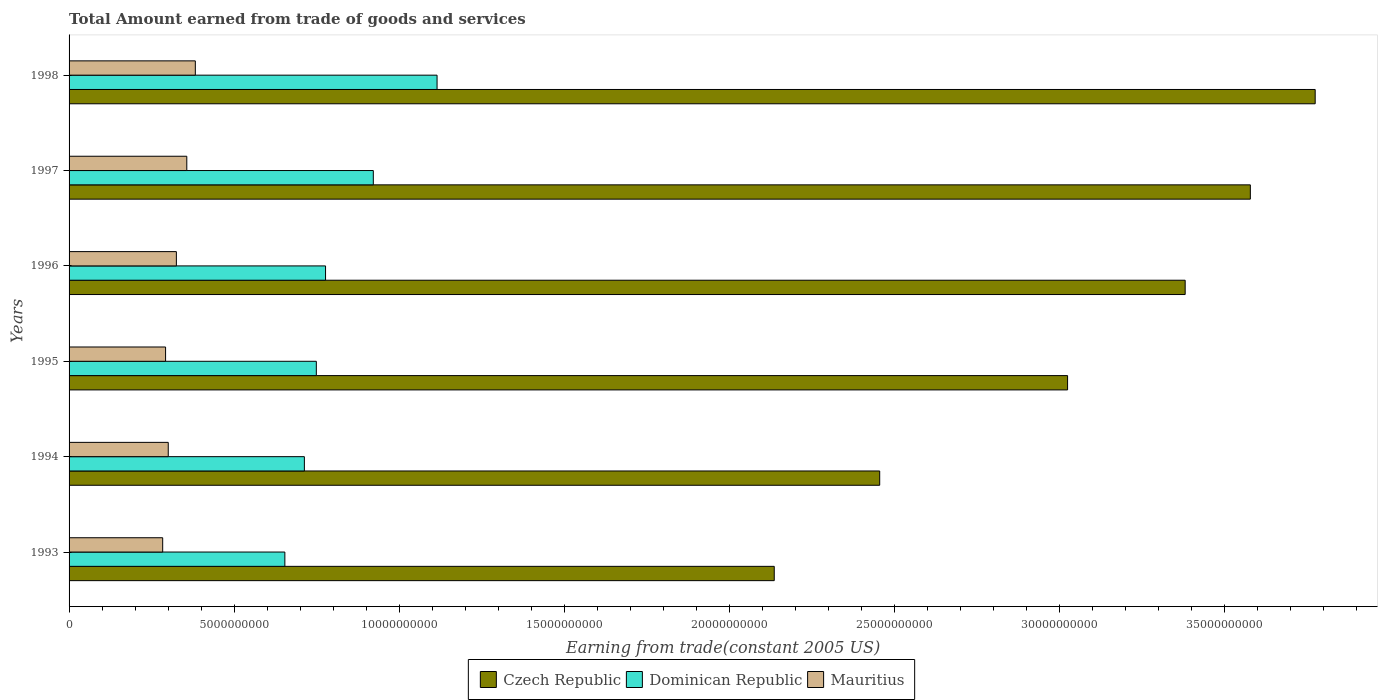How many different coloured bars are there?
Offer a very short reply. 3. How many groups of bars are there?
Offer a very short reply. 6. Are the number of bars on each tick of the Y-axis equal?
Your response must be concise. Yes. How many bars are there on the 1st tick from the top?
Make the answer very short. 3. How many bars are there on the 1st tick from the bottom?
Ensure brevity in your answer.  3. What is the label of the 3rd group of bars from the top?
Keep it short and to the point. 1996. What is the total amount earned by trading goods and services in Dominican Republic in 1993?
Your answer should be compact. 6.54e+09. Across all years, what is the maximum total amount earned by trading goods and services in Dominican Republic?
Make the answer very short. 1.12e+1. Across all years, what is the minimum total amount earned by trading goods and services in Mauritius?
Give a very brief answer. 2.84e+09. In which year was the total amount earned by trading goods and services in Dominican Republic maximum?
Your answer should be compact. 1998. What is the total total amount earned by trading goods and services in Czech Republic in the graph?
Offer a terse response. 1.84e+11. What is the difference between the total amount earned by trading goods and services in Czech Republic in 1994 and that in 1995?
Your response must be concise. -5.69e+09. What is the difference between the total amount earned by trading goods and services in Mauritius in 1994 and the total amount earned by trading goods and services in Dominican Republic in 1997?
Offer a very short reply. -6.21e+09. What is the average total amount earned by trading goods and services in Mauritius per year?
Offer a very short reply. 3.24e+09. In the year 1998, what is the difference between the total amount earned by trading goods and services in Czech Republic and total amount earned by trading goods and services in Mauritius?
Offer a terse response. 3.39e+1. In how many years, is the total amount earned by trading goods and services in Dominican Republic greater than 37000000000 US$?
Your answer should be very brief. 0. What is the ratio of the total amount earned by trading goods and services in Czech Republic in 1995 to that in 1997?
Your response must be concise. 0.85. What is the difference between the highest and the second highest total amount earned by trading goods and services in Dominican Republic?
Offer a very short reply. 1.93e+09. What is the difference between the highest and the lowest total amount earned by trading goods and services in Czech Republic?
Provide a succinct answer. 1.64e+1. In how many years, is the total amount earned by trading goods and services in Mauritius greater than the average total amount earned by trading goods and services in Mauritius taken over all years?
Keep it short and to the point. 3. Is the sum of the total amount earned by trading goods and services in Dominican Republic in 1994 and 1995 greater than the maximum total amount earned by trading goods and services in Czech Republic across all years?
Provide a short and direct response. No. What does the 3rd bar from the top in 1993 represents?
Offer a terse response. Czech Republic. What does the 2nd bar from the bottom in 1998 represents?
Offer a very short reply. Dominican Republic. How many bars are there?
Offer a terse response. 18. What is the difference between two consecutive major ticks on the X-axis?
Keep it short and to the point. 5.00e+09. How many legend labels are there?
Offer a terse response. 3. How are the legend labels stacked?
Keep it short and to the point. Horizontal. What is the title of the graph?
Your answer should be compact. Total Amount earned from trade of goods and services. What is the label or title of the X-axis?
Provide a short and direct response. Earning from trade(constant 2005 US). What is the Earning from trade(constant 2005 US) of Czech Republic in 1993?
Give a very brief answer. 2.14e+1. What is the Earning from trade(constant 2005 US) in Dominican Republic in 1993?
Give a very brief answer. 6.54e+09. What is the Earning from trade(constant 2005 US) in Mauritius in 1993?
Ensure brevity in your answer.  2.84e+09. What is the Earning from trade(constant 2005 US) of Czech Republic in 1994?
Make the answer very short. 2.46e+1. What is the Earning from trade(constant 2005 US) of Dominican Republic in 1994?
Your response must be concise. 7.13e+09. What is the Earning from trade(constant 2005 US) of Mauritius in 1994?
Keep it short and to the point. 3.01e+09. What is the Earning from trade(constant 2005 US) of Czech Republic in 1995?
Make the answer very short. 3.03e+1. What is the Earning from trade(constant 2005 US) in Dominican Republic in 1995?
Your response must be concise. 7.49e+09. What is the Earning from trade(constant 2005 US) of Mauritius in 1995?
Make the answer very short. 2.92e+09. What is the Earning from trade(constant 2005 US) in Czech Republic in 1996?
Offer a terse response. 3.38e+1. What is the Earning from trade(constant 2005 US) of Dominican Republic in 1996?
Your answer should be very brief. 7.77e+09. What is the Earning from trade(constant 2005 US) in Mauritius in 1996?
Offer a very short reply. 3.25e+09. What is the Earning from trade(constant 2005 US) of Czech Republic in 1997?
Offer a terse response. 3.58e+1. What is the Earning from trade(constant 2005 US) of Dominican Republic in 1997?
Keep it short and to the point. 9.22e+09. What is the Earning from trade(constant 2005 US) in Mauritius in 1997?
Your answer should be very brief. 3.57e+09. What is the Earning from trade(constant 2005 US) of Czech Republic in 1998?
Your answer should be compact. 3.78e+1. What is the Earning from trade(constant 2005 US) of Dominican Republic in 1998?
Provide a succinct answer. 1.12e+1. What is the Earning from trade(constant 2005 US) in Mauritius in 1998?
Make the answer very short. 3.83e+09. Across all years, what is the maximum Earning from trade(constant 2005 US) in Czech Republic?
Your response must be concise. 3.78e+1. Across all years, what is the maximum Earning from trade(constant 2005 US) in Dominican Republic?
Your response must be concise. 1.12e+1. Across all years, what is the maximum Earning from trade(constant 2005 US) of Mauritius?
Your answer should be very brief. 3.83e+09. Across all years, what is the minimum Earning from trade(constant 2005 US) in Czech Republic?
Ensure brevity in your answer.  2.14e+1. Across all years, what is the minimum Earning from trade(constant 2005 US) of Dominican Republic?
Offer a terse response. 6.54e+09. Across all years, what is the minimum Earning from trade(constant 2005 US) of Mauritius?
Your answer should be compact. 2.84e+09. What is the total Earning from trade(constant 2005 US) in Czech Republic in the graph?
Your answer should be compact. 1.84e+11. What is the total Earning from trade(constant 2005 US) in Dominican Republic in the graph?
Ensure brevity in your answer.  4.93e+1. What is the total Earning from trade(constant 2005 US) in Mauritius in the graph?
Your response must be concise. 1.94e+1. What is the difference between the Earning from trade(constant 2005 US) in Czech Republic in 1993 and that in 1994?
Your response must be concise. -3.20e+09. What is the difference between the Earning from trade(constant 2005 US) of Dominican Republic in 1993 and that in 1994?
Offer a terse response. -5.92e+08. What is the difference between the Earning from trade(constant 2005 US) of Mauritius in 1993 and that in 1994?
Give a very brief answer. -1.69e+08. What is the difference between the Earning from trade(constant 2005 US) of Czech Republic in 1993 and that in 1995?
Offer a very short reply. -8.89e+09. What is the difference between the Earning from trade(constant 2005 US) of Dominican Republic in 1993 and that in 1995?
Give a very brief answer. -9.54e+08. What is the difference between the Earning from trade(constant 2005 US) in Mauritius in 1993 and that in 1995?
Your answer should be very brief. -8.80e+07. What is the difference between the Earning from trade(constant 2005 US) of Czech Republic in 1993 and that in 1996?
Your answer should be very brief. -1.25e+1. What is the difference between the Earning from trade(constant 2005 US) of Dominican Republic in 1993 and that in 1996?
Give a very brief answer. -1.23e+09. What is the difference between the Earning from trade(constant 2005 US) of Mauritius in 1993 and that in 1996?
Offer a terse response. -4.15e+08. What is the difference between the Earning from trade(constant 2005 US) of Czech Republic in 1993 and that in 1997?
Offer a terse response. -1.44e+1. What is the difference between the Earning from trade(constant 2005 US) in Dominican Republic in 1993 and that in 1997?
Keep it short and to the point. -2.68e+09. What is the difference between the Earning from trade(constant 2005 US) of Mauritius in 1993 and that in 1997?
Your answer should be very brief. -7.31e+08. What is the difference between the Earning from trade(constant 2005 US) of Czech Republic in 1993 and that in 1998?
Provide a short and direct response. -1.64e+1. What is the difference between the Earning from trade(constant 2005 US) in Dominican Republic in 1993 and that in 1998?
Keep it short and to the point. -4.61e+09. What is the difference between the Earning from trade(constant 2005 US) in Mauritius in 1993 and that in 1998?
Your response must be concise. -9.90e+08. What is the difference between the Earning from trade(constant 2005 US) of Czech Republic in 1994 and that in 1995?
Your answer should be very brief. -5.69e+09. What is the difference between the Earning from trade(constant 2005 US) of Dominican Republic in 1994 and that in 1995?
Give a very brief answer. -3.62e+08. What is the difference between the Earning from trade(constant 2005 US) of Mauritius in 1994 and that in 1995?
Your answer should be very brief. 8.09e+07. What is the difference between the Earning from trade(constant 2005 US) of Czech Republic in 1994 and that in 1996?
Your answer should be compact. -9.26e+09. What is the difference between the Earning from trade(constant 2005 US) in Dominican Republic in 1994 and that in 1996?
Your response must be concise. -6.42e+08. What is the difference between the Earning from trade(constant 2005 US) of Mauritius in 1994 and that in 1996?
Provide a short and direct response. -2.46e+08. What is the difference between the Earning from trade(constant 2005 US) in Czech Republic in 1994 and that in 1997?
Provide a short and direct response. -1.12e+1. What is the difference between the Earning from trade(constant 2005 US) of Dominican Republic in 1994 and that in 1997?
Keep it short and to the point. -2.09e+09. What is the difference between the Earning from trade(constant 2005 US) of Mauritius in 1994 and that in 1997?
Your answer should be very brief. -5.62e+08. What is the difference between the Earning from trade(constant 2005 US) of Czech Republic in 1994 and that in 1998?
Keep it short and to the point. -1.32e+1. What is the difference between the Earning from trade(constant 2005 US) in Dominican Republic in 1994 and that in 1998?
Provide a succinct answer. -4.02e+09. What is the difference between the Earning from trade(constant 2005 US) in Mauritius in 1994 and that in 1998?
Your response must be concise. -8.21e+08. What is the difference between the Earning from trade(constant 2005 US) of Czech Republic in 1995 and that in 1996?
Keep it short and to the point. -3.56e+09. What is the difference between the Earning from trade(constant 2005 US) in Dominican Republic in 1995 and that in 1996?
Ensure brevity in your answer.  -2.80e+08. What is the difference between the Earning from trade(constant 2005 US) in Mauritius in 1995 and that in 1996?
Offer a very short reply. -3.27e+08. What is the difference between the Earning from trade(constant 2005 US) in Czech Republic in 1995 and that in 1997?
Ensure brevity in your answer.  -5.54e+09. What is the difference between the Earning from trade(constant 2005 US) of Dominican Republic in 1995 and that in 1997?
Offer a very short reply. -1.73e+09. What is the difference between the Earning from trade(constant 2005 US) of Mauritius in 1995 and that in 1997?
Provide a short and direct response. -6.43e+08. What is the difference between the Earning from trade(constant 2005 US) of Czech Republic in 1995 and that in 1998?
Your answer should be compact. -7.50e+09. What is the difference between the Earning from trade(constant 2005 US) of Dominican Republic in 1995 and that in 1998?
Offer a terse response. -3.66e+09. What is the difference between the Earning from trade(constant 2005 US) in Mauritius in 1995 and that in 1998?
Offer a terse response. -9.02e+08. What is the difference between the Earning from trade(constant 2005 US) of Czech Republic in 1996 and that in 1997?
Your response must be concise. -1.97e+09. What is the difference between the Earning from trade(constant 2005 US) in Dominican Republic in 1996 and that in 1997?
Provide a succinct answer. -1.45e+09. What is the difference between the Earning from trade(constant 2005 US) of Mauritius in 1996 and that in 1997?
Your answer should be compact. -3.16e+08. What is the difference between the Earning from trade(constant 2005 US) of Czech Republic in 1996 and that in 1998?
Ensure brevity in your answer.  -3.94e+09. What is the difference between the Earning from trade(constant 2005 US) of Dominican Republic in 1996 and that in 1998?
Provide a short and direct response. -3.38e+09. What is the difference between the Earning from trade(constant 2005 US) of Mauritius in 1996 and that in 1998?
Offer a very short reply. -5.74e+08. What is the difference between the Earning from trade(constant 2005 US) of Czech Republic in 1997 and that in 1998?
Make the answer very short. -1.97e+09. What is the difference between the Earning from trade(constant 2005 US) of Dominican Republic in 1997 and that in 1998?
Offer a very short reply. -1.93e+09. What is the difference between the Earning from trade(constant 2005 US) in Mauritius in 1997 and that in 1998?
Offer a terse response. -2.59e+08. What is the difference between the Earning from trade(constant 2005 US) of Czech Republic in 1993 and the Earning from trade(constant 2005 US) of Dominican Republic in 1994?
Provide a short and direct response. 1.42e+1. What is the difference between the Earning from trade(constant 2005 US) in Czech Republic in 1993 and the Earning from trade(constant 2005 US) in Mauritius in 1994?
Provide a succinct answer. 1.84e+1. What is the difference between the Earning from trade(constant 2005 US) in Dominican Republic in 1993 and the Earning from trade(constant 2005 US) in Mauritius in 1994?
Keep it short and to the point. 3.53e+09. What is the difference between the Earning from trade(constant 2005 US) in Czech Republic in 1993 and the Earning from trade(constant 2005 US) in Dominican Republic in 1995?
Your response must be concise. 1.39e+1. What is the difference between the Earning from trade(constant 2005 US) in Czech Republic in 1993 and the Earning from trade(constant 2005 US) in Mauritius in 1995?
Make the answer very short. 1.84e+1. What is the difference between the Earning from trade(constant 2005 US) of Dominican Republic in 1993 and the Earning from trade(constant 2005 US) of Mauritius in 1995?
Provide a short and direct response. 3.61e+09. What is the difference between the Earning from trade(constant 2005 US) of Czech Republic in 1993 and the Earning from trade(constant 2005 US) of Dominican Republic in 1996?
Your answer should be very brief. 1.36e+1. What is the difference between the Earning from trade(constant 2005 US) of Czech Republic in 1993 and the Earning from trade(constant 2005 US) of Mauritius in 1996?
Offer a very short reply. 1.81e+1. What is the difference between the Earning from trade(constant 2005 US) of Dominican Republic in 1993 and the Earning from trade(constant 2005 US) of Mauritius in 1996?
Offer a terse response. 3.29e+09. What is the difference between the Earning from trade(constant 2005 US) of Czech Republic in 1993 and the Earning from trade(constant 2005 US) of Dominican Republic in 1997?
Your answer should be compact. 1.22e+1. What is the difference between the Earning from trade(constant 2005 US) of Czech Republic in 1993 and the Earning from trade(constant 2005 US) of Mauritius in 1997?
Offer a terse response. 1.78e+1. What is the difference between the Earning from trade(constant 2005 US) in Dominican Republic in 1993 and the Earning from trade(constant 2005 US) in Mauritius in 1997?
Ensure brevity in your answer.  2.97e+09. What is the difference between the Earning from trade(constant 2005 US) of Czech Republic in 1993 and the Earning from trade(constant 2005 US) of Dominican Republic in 1998?
Provide a short and direct response. 1.02e+1. What is the difference between the Earning from trade(constant 2005 US) in Czech Republic in 1993 and the Earning from trade(constant 2005 US) in Mauritius in 1998?
Offer a very short reply. 1.75e+1. What is the difference between the Earning from trade(constant 2005 US) in Dominican Republic in 1993 and the Earning from trade(constant 2005 US) in Mauritius in 1998?
Your answer should be compact. 2.71e+09. What is the difference between the Earning from trade(constant 2005 US) of Czech Republic in 1994 and the Earning from trade(constant 2005 US) of Dominican Republic in 1995?
Make the answer very short. 1.71e+1. What is the difference between the Earning from trade(constant 2005 US) of Czech Republic in 1994 and the Earning from trade(constant 2005 US) of Mauritius in 1995?
Give a very brief answer. 2.16e+1. What is the difference between the Earning from trade(constant 2005 US) of Dominican Republic in 1994 and the Earning from trade(constant 2005 US) of Mauritius in 1995?
Offer a very short reply. 4.21e+09. What is the difference between the Earning from trade(constant 2005 US) of Czech Republic in 1994 and the Earning from trade(constant 2005 US) of Dominican Republic in 1996?
Offer a terse response. 1.68e+1. What is the difference between the Earning from trade(constant 2005 US) of Czech Republic in 1994 and the Earning from trade(constant 2005 US) of Mauritius in 1996?
Provide a succinct answer. 2.13e+1. What is the difference between the Earning from trade(constant 2005 US) of Dominican Republic in 1994 and the Earning from trade(constant 2005 US) of Mauritius in 1996?
Your answer should be very brief. 3.88e+09. What is the difference between the Earning from trade(constant 2005 US) in Czech Republic in 1994 and the Earning from trade(constant 2005 US) in Dominican Republic in 1997?
Ensure brevity in your answer.  1.53e+1. What is the difference between the Earning from trade(constant 2005 US) in Czech Republic in 1994 and the Earning from trade(constant 2005 US) in Mauritius in 1997?
Ensure brevity in your answer.  2.10e+1. What is the difference between the Earning from trade(constant 2005 US) in Dominican Republic in 1994 and the Earning from trade(constant 2005 US) in Mauritius in 1997?
Give a very brief answer. 3.56e+09. What is the difference between the Earning from trade(constant 2005 US) of Czech Republic in 1994 and the Earning from trade(constant 2005 US) of Dominican Republic in 1998?
Your answer should be compact. 1.34e+1. What is the difference between the Earning from trade(constant 2005 US) of Czech Republic in 1994 and the Earning from trade(constant 2005 US) of Mauritius in 1998?
Provide a short and direct response. 2.07e+1. What is the difference between the Earning from trade(constant 2005 US) of Dominican Republic in 1994 and the Earning from trade(constant 2005 US) of Mauritius in 1998?
Provide a short and direct response. 3.30e+09. What is the difference between the Earning from trade(constant 2005 US) in Czech Republic in 1995 and the Earning from trade(constant 2005 US) in Dominican Republic in 1996?
Provide a short and direct response. 2.25e+1. What is the difference between the Earning from trade(constant 2005 US) in Czech Republic in 1995 and the Earning from trade(constant 2005 US) in Mauritius in 1996?
Keep it short and to the point. 2.70e+1. What is the difference between the Earning from trade(constant 2005 US) of Dominican Republic in 1995 and the Earning from trade(constant 2005 US) of Mauritius in 1996?
Give a very brief answer. 4.24e+09. What is the difference between the Earning from trade(constant 2005 US) of Czech Republic in 1995 and the Earning from trade(constant 2005 US) of Dominican Republic in 1997?
Provide a succinct answer. 2.10e+1. What is the difference between the Earning from trade(constant 2005 US) in Czech Republic in 1995 and the Earning from trade(constant 2005 US) in Mauritius in 1997?
Provide a short and direct response. 2.67e+1. What is the difference between the Earning from trade(constant 2005 US) in Dominican Republic in 1995 and the Earning from trade(constant 2005 US) in Mauritius in 1997?
Offer a very short reply. 3.93e+09. What is the difference between the Earning from trade(constant 2005 US) in Czech Republic in 1995 and the Earning from trade(constant 2005 US) in Dominican Republic in 1998?
Ensure brevity in your answer.  1.91e+1. What is the difference between the Earning from trade(constant 2005 US) in Czech Republic in 1995 and the Earning from trade(constant 2005 US) in Mauritius in 1998?
Offer a terse response. 2.64e+1. What is the difference between the Earning from trade(constant 2005 US) in Dominican Republic in 1995 and the Earning from trade(constant 2005 US) in Mauritius in 1998?
Keep it short and to the point. 3.67e+09. What is the difference between the Earning from trade(constant 2005 US) in Czech Republic in 1996 and the Earning from trade(constant 2005 US) in Dominican Republic in 1997?
Your answer should be very brief. 2.46e+1. What is the difference between the Earning from trade(constant 2005 US) of Czech Republic in 1996 and the Earning from trade(constant 2005 US) of Mauritius in 1997?
Offer a very short reply. 3.03e+1. What is the difference between the Earning from trade(constant 2005 US) in Dominican Republic in 1996 and the Earning from trade(constant 2005 US) in Mauritius in 1997?
Make the answer very short. 4.20e+09. What is the difference between the Earning from trade(constant 2005 US) of Czech Republic in 1996 and the Earning from trade(constant 2005 US) of Dominican Republic in 1998?
Make the answer very short. 2.27e+1. What is the difference between the Earning from trade(constant 2005 US) in Czech Republic in 1996 and the Earning from trade(constant 2005 US) in Mauritius in 1998?
Your answer should be compact. 3.00e+1. What is the difference between the Earning from trade(constant 2005 US) of Dominican Republic in 1996 and the Earning from trade(constant 2005 US) of Mauritius in 1998?
Ensure brevity in your answer.  3.95e+09. What is the difference between the Earning from trade(constant 2005 US) in Czech Republic in 1997 and the Earning from trade(constant 2005 US) in Dominican Republic in 1998?
Your answer should be very brief. 2.46e+1. What is the difference between the Earning from trade(constant 2005 US) in Czech Republic in 1997 and the Earning from trade(constant 2005 US) in Mauritius in 1998?
Ensure brevity in your answer.  3.20e+1. What is the difference between the Earning from trade(constant 2005 US) of Dominican Republic in 1997 and the Earning from trade(constant 2005 US) of Mauritius in 1998?
Provide a short and direct response. 5.39e+09. What is the average Earning from trade(constant 2005 US) in Czech Republic per year?
Offer a very short reply. 3.06e+1. What is the average Earning from trade(constant 2005 US) of Dominican Republic per year?
Offer a very short reply. 8.22e+09. What is the average Earning from trade(constant 2005 US) of Mauritius per year?
Keep it short and to the point. 3.24e+09. In the year 1993, what is the difference between the Earning from trade(constant 2005 US) in Czech Republic and Earning from trade(constant 2005 US) in Dominican Republic?
Your answer should be compact. 1.48e+1. In the year 1993, what is the difference between the Earning from trade(constant 2005 US) of Czech Republic and Earning from trade(constant 2005 US) of Mauritius?
Your response must be concise. 1.85e+1. In the year 1993, what is the difference between the Earning from trade(constant 2005 US) in Dominican Republic and Earning from trade(constant 2005 US) in Mauritius?
Keep it short and to the point. 3.70e+09. In the year 1994, what is the difference between the Earning from trade(constant 2005 US) in Czech Republic and Earning from trade(constant 2005 US) in Dominican Republic?
Your response must be concise. 1.74e+1. In the year 1994, what is the difference between the Earning from trade(constant 2005 US) of Czech Republic and Earning from trade(constant 2005 US) of Mauritius?
Keep it short and to the point. 2.16e+1. In the year 1994, what is the difference between the Earning from trade(constant 2005 US) in Dominican Republic and Earning from trade(constant 2005 US) in Mauritius?
Offer a terse response. 4.13e+09. In the year 1995, what is the difference between the Earning from trade(constant 2005 US) of Czech Republic and Earning from trade(constant 2005 US) of Dominican Republic?
Provide a succinct answer. 2.28e+1. In the year 1995, what is the difference between the Earning from trade(constant 2005 US) in Czech Republic and Earning from trade(constant 2005 US) in Mauritius?
Offer a very short reply. 2.73e+1. In the year 1995, what is the difference between the Earning from trade(constant 2005 US) in Dominican Republic and Earning from trade(constant 2005 US) in Mauritius?
Offer a terse response. 4.57e+09. In the year 1996, what is the difference between the Earning from trade(constant 2005 US) of Czech Republic and Earning from trade(constant 2005 US) of Dominican Republic?
Ensure brevity in your answer.  2.61e+1. In the year 1996, what is the difference between the Earning from trade(constant 2005 US) in Czech Republic and Earning from trade(constant 2005 US) in Mauritius?
Provide a succinct answer. 3.06e+1. In the year 1996, what is the difference between the Earning from trade(constant 2005 US) in Dominican Republic and Earning from trade(constant 2005 US) in Mauritius?
Make the answer very short. 4.52e+09. In the year 1997, what is the difference between the Earning from trade(constant 2005 US) in Czech Republic and Earning from trade(constant 2005 US) in Dominican Republic?
Keep it short and to the point. 2.66e+1. In the year 1997, what is the difference between the Earning from trade(constant 2005 US) in Czech Republic and Earning from trade(constant 2005 US) in Mauritius?
Keep it short and to the point. 3.22e+1. In the year 1997, what is the difference between the Earning from trade(constant 2005 US) in Dominican Republic and Earning from trade(constant 2005 US) in Mauritius?
Ensure brevity in your answer.  5.65e+09. In the year 1998, what is the difference between the Earning from trade(constant 2005 US) in Czech Republic and Earning from trade(constant 2005 US) in Dominican Republic?
Your response must be concise. 2.66e+1. In the year 1998, what is the difference between the Earning from trade(constant 2005 US) of Czech Republic and Earning from trade(constant 2005 US) of Mauritius?
Give a very brief answer. 3.39e+1. In the year 1998, what is the difference between the Earning from trade(constant 2005 US) of Dominican Republic and Earning from trade(constant 2005 US) of Mauritius?
Provide a short and direct response. 7.33e+09. What is the ratio of the Earning from trade(constant 2005 US) of Czech Republic in 1993 to that in 1994?
Your answer should be very brief. 0.87. What is the ratio of the Earning from trade(constant 2005 US) of Dominican Republic in 1993 to that in 1994?
Offer a terse response. 0.92. What is the ratio of the Earning from trade(constant 2005 US) in Mauritius in 1993 to that in 1994?
Your response must be concise. 0.94. What is the ratio of the Earning from trade(constant 2005 US) of Czech Republic in 1993 to that in 1995?
Your response must be concise. 0.71. What is the ratio of the Earning from trade(constant 2005 US) in Dominican Republic in 1993 to that in 1995?
Your answer should be very brief. 0.87. What is the ratio of the Earning from trade(constant 2005 US) in Mauritius in 1993 to that in 1995?
Keep it short and to the point. 0.97. What is the ratio of the Earning from trade(constant 2005 US) of Czech Republic in 1993 to that in 1996?
Offer a terse response. 0.63. What is the ratio of the Earning from trade(constant 2005 US) in Dominican Republic in 1993 to that in 1996?
Your response must be concise. 0.84. What is the ratio of the Earning from trade(constant 2005 US) of Mauritius in 1993 to that in 1996?
Your answer should be compact. 0.87. What is the ratio of the Earning from trade(constant 2005 US) of Czech Republic in 1993 to that in 1997?
Make the answer very short. 0.6. What is the ratio of the Earning from trade(constant 2005 US) of Dominican Republic in 1993 to that in 1997?
Your response must be concise. 0.71. What is the ratio of the Earning from trade(constant 2005 US) in Mauritius in 1993 to that in 1997?
Make the answer very short. 0.8. What is the ratio of the Earning from trade(constant 2005 US) of Czech Republic in 1993 to that in 1998?
Your answer should be compact. 0.57. What is the ratio of the Earning from trade(constant 2005 US) in Dominican Republic in 1993 to that in 1998?
Offer a very short reply. 0.59. What is the ratio of the Earning from trade(constant 2005 US) in Mauritius in 1993 to that in 1998?
Your answer should be compact. 0.74. What is the ratio of the Earning from trade(constant 2005 US) of Czech Republic in 1994 to that in 1995?
Provide a short and direct response. 0.81. What is the ratio of the Earning from trade(constant 2005 US) of Dominican Republic in 1994 to that in 1995?
Make the answer very short. 0.95. What is the ratio of the Earning from trade(constant 2005 US) in Mauritius in 1994 to that in 1995?
Offer a terse response. 1.03. What is the ratio of the Earning from trade(constant 2005 US) of Czech Republic in 1994 to that in 1996?
Your answer should be compact. 0.73. What is the ratio of the Earning from trade(constant 2005 US) of Dominican Republic in 1994 to that in 1996?
Your answer should be compact. 0.92. What is the ratio of the Earning from trade(constant 2005 US) in Mauritius in 1994 to that in 1996?
Your answer should be very brief. 0.92. What is the ratio of the Earning from trade(constant 2005 US) of Czech Republic in 1994 to that in 1997?
Offer a terse response. 0.69. What is the ratio of the Earning from trade(constant 2005 US) in Dominican Republic in 1994 to that in 1997?
Your response must be concise. 0.77. What is the ratio of the Earning from trade(constant 2005 US) of Mauritius in 1994 to that in 1997?
Ensure brevity in your answer.  0.84. What is the ratio of the Earning from trade(constant 2005 US) in Czech Republic in 1994 to that in 1998?
Provide a short and direct response. 0.65. What is the ratio of the Earning from trade(constant 2005 US) of Dominican Republic in 1994 to that in 1998?
Offer a very short reply. 0.64. What is the ratio of the Earning from trade(constant 2005 US) in Mauritius in 1994 to that in 1998?
Your answer should be compact. 0.79. What is the ratio of the Earning from trade(constant 2005 US) of Czech Republic in 1995 to that in 1996?
Your response must be concise. 0.89. What is the ratio of the Earning from trade(constant 2005 US) in Mauritius in 1995 to that in 1996?
Keep it short and to the point. 0.9. What is the ratio of the Earning from trade(constant 2005 US) of Czech Republic in 1995 to that in 1997?
Provide a succinct answer. 0.85. What is the ratio of the Earning from trade(constant 2005 US) of Dominican Republic in 1995 to that in 1997?
Your answer should be compact. 0.81. What is the ratio of the Earning from trade(constant 2005 US) in Mauritius in 1995 to that in 1997?
Make the answer very short. 0.82. What is the ratio of the Earning from trade(constant 2005 US) of Czech Republic in 1995 to that in 1998?
Your response must be concise. 0.8. What is the ratio of the Earning from trade(constant 2005 US) of Dominican Republic in 1995 to that in 1998?
Keep it short and to the point. 0.67. What is the ratio of the Earning from trade(constant 2005 US) of Mauritius in 1995 to that in 1998?
Offer a very short reply. 0.76. What is the ratio of the Earning from trade(constant 2005 US) in Czech Republic in 1996 to that in 1997?
Your answer should be very brief. 0.94. What is the ratio of the Earning from trade(constant 2005 US) in Dominican Republic in 1996 to that in 1997?
Offer a terse response. 0.84. What is the ratio of the Earning from trade(constant 2005 US) in Mauritius in 1996 to that in 1997?
Your response must be concise. 0.91. What is the ratio of the Earning from trade(constant 2005 US) in Czech Republic in 1996 to that in 1998?
Offer a terse response. 0.9. What is the ratio of the Earning from trade(constant 2005 US) of Dominican Republic in 1996 to that in 1998?
Provide a short and direct response. 0.7. What is the ratio of the Earning from trade(constant 2005 US) of Mauritius in 1996 to that in 1998?
Ensure brevity in your answer.  0.85. What is the ratio of the Earning from trade(constant 2005 US) in Czech Republic in 1997 to that in 1998?
Offer a very short reply. 0.95. What is the ratio of the Earning from trade(constant 2005 US) in Dominican Republic in 1997 to that in 1998?
Make the answer very short. 0.83. What is the ratio of the Earning from trade(constant 2005 US) in Mauritius in 1997 to that in 1998?
Your answer should be very brief. 0.93. What is the difference between the highest and the second highest Earning from trade(constant 2005 US) of Czech Republic?
Give a very brief answer. 1.97e+09. What is the difference between the highest and the second highest Earning from trade(constant 2005 US) in Dominican Republic?
Make the answer very short. 1.93e+09. What is the difference between the highest and the second highest Earning from trade(constant 2005 US) of Mauritius?
Keep it short and to the point. 2.59e+08. What is the difference between the highest and the lowest Earning from trade(constant 2005 US) in Czech Republic?
Provide a succinct answer. 1.64e+1. What is the difference between the highest and the lowest Earning from trade(constant 2005 US) of Dominican Republic?
Offer a very short reply. 4.61e+09. What is the difference between the highest and the lowest Earning from trade(constant 2005 US) of Mauritius?
Your answer should be compact. 9.90e+08. 